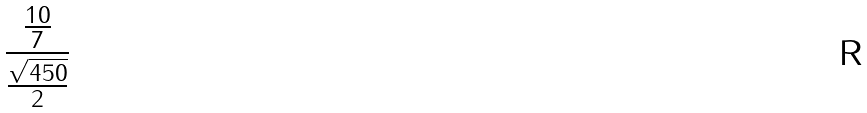Convert formula to latex. <formula><loc_0><loc_0><loc_500><loc_500>\frac { \frac { 1 0 } { 7 } } { \frac { \sqrt { 4 5 0 } } { 2 } }</formula> 